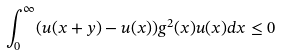<formula> <loc_0><loc_0><loc_500><loc_500>\int _ { 0 } ^ { \infty } ( u ( x + y ) - u ( x ) ) g ^ { 2 } ( x ) u ( x ) d x \leq 0</formula> 